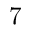<formula> <loc_0><loc_0><loc_500><loc_500>7</formula> 